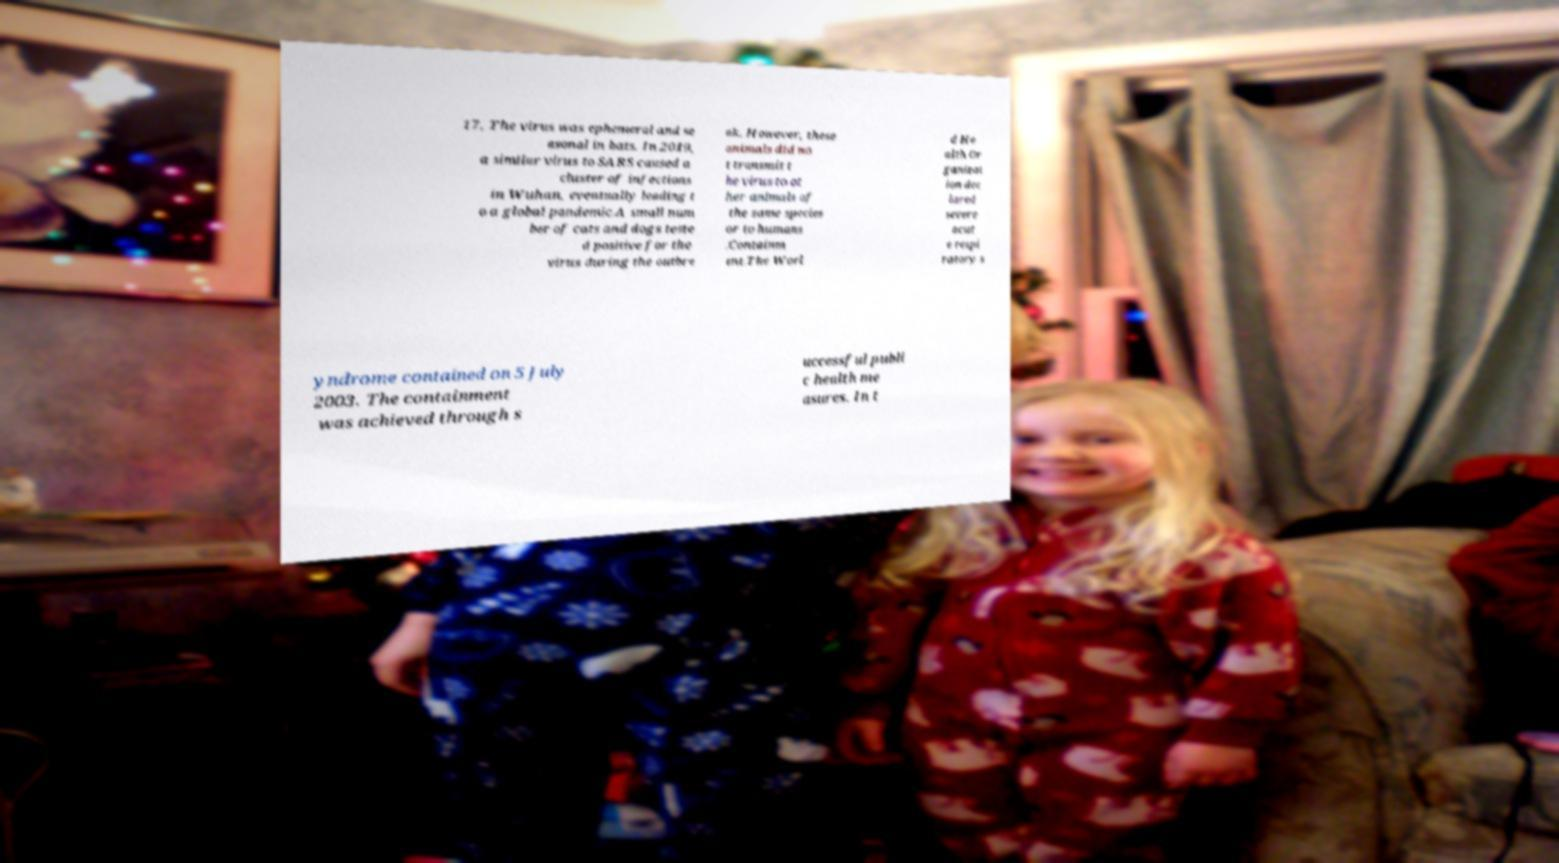There's text embedded in this image that I need extracted. Can you transcribe it verbatim? 17, The virus was ephemeral and se asonal in bats. In 2019, a similar virus to SARS caused a cluster of infections in Wuhan, eventually leading t o a global pandemic.A small num ber of cats and dogs teste d positive for the virus during the outbre ak. However, these animals did no t transmit t he virus to ot her animals of the same species or to humans .Containm ent.The Worl d He alth Or ganizat ion dec lared severe acut e respi ratory s yndrome contained on 5 July 2003. The containment was achieved through s uccessful publi c health me asures. In t 